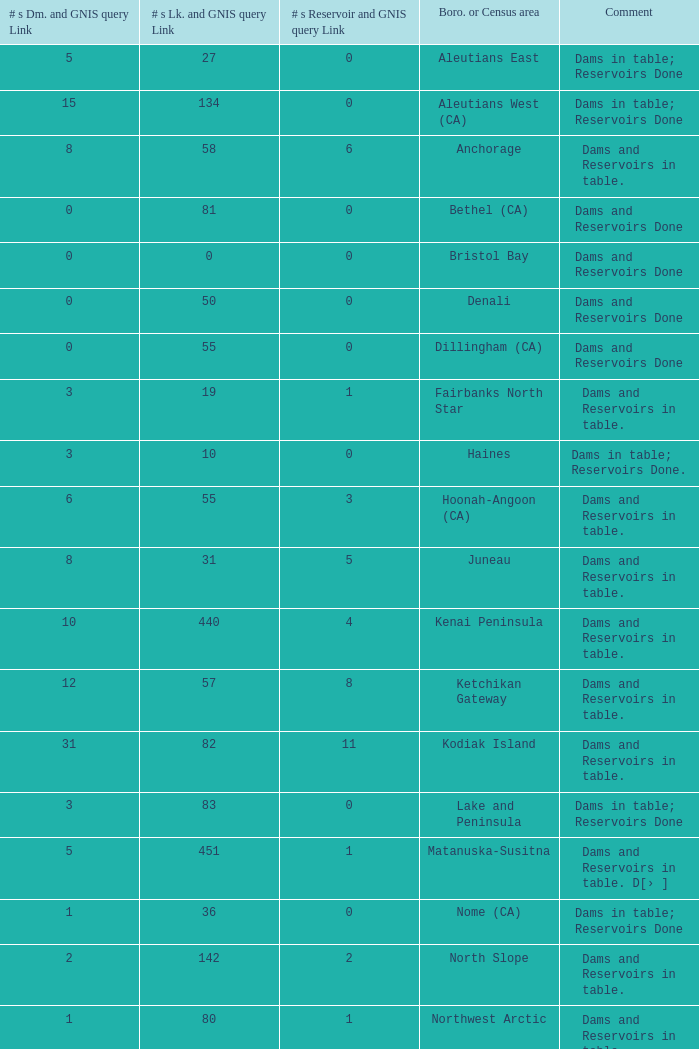Give me the full table as a dictionary. {'header': ['# s Dm. and GNIS query Link', '# s Lk. and GNIS query Link', '# s Reservoir and GNIS query Link', 'Boro. or Census area', 'Comment'], 'rows': [['5', '27', '0', 'Aleutians East', 'Dams in table; Reservoirs Done'], ['15', '134', '0', 'Aleutians West (CA)', 'Dams in table; Reservoirs Done'], ['8', '58', '6', 'Anchorage', 'Dams and Reservoirs in table.'], ['0', '81', '0', 'Bethel (CA)', 'Dams and Reservoirs Done'], ['0', '0', '0', 'Bristol Bay', 'Dams and Reservoirs Done'], ['0', '50', '0', 'Denali', 'Dams and Reservoirs Done'], ['0', '55', '0', 'Dillingham (CA)', 'Dams and Reservoirs Done'], ['3', '19', '1', 'Fairbanks North Star', 'Dams and Reservoirs in table.'], ['3', '10', '0', 'Haines', 'Dams in table; Reservoirs Done.'], ['6', '55', '3', 'Hoonah-Angoon (CA)', 'Dams and Reservoirs in table.'], ['8', '31', '5', 'Juneau', 'Dams and Reservoirs in table.'], ['10', '440', '4', 'Kenai Peninsula', 'Dams and Reservoirs in table.'], ['12', '57', '8', 'Ketchikan Gateway', 'Dams and Reservoirs in table.'], ['31', '82', '11', 'Kodiak Island', 'Dams and Reservoirs in table.'], ['3', '83', '0', 'Lake and Peninsula', 'Dams in table; Reservoirs Done'], ['5', '451', '1', 'Matanuska-Susitna', 'Dams and Reservoirs in table. D[› ]'], ['1', '36', '0', 'Nome (CA)', 'Dams in table; Reservoirs Done'], ['2', '142', '2', 'North Slope', 'Dams and Reservoirs in table.'], ['1', '80', '1', 'Northwest Arctic', 'Dams and Reservoirs in table.'], ['9', '163', '4', 'P. of Wales-O. Ketchikan (CA)', 'Dams and Reservoirs in table.'], ['9', '90', '3', 'Sitka', 'Dams and Reservoirs in table.'], ['3', '9', '3', 'Skagway', 'Dams and Reservoirs in table.'], ['0', '130', '0', 'Southeast Fairbanks (CA)', 'Dams and Reservoirs in table.'], ['22', '293', '10', 'Valdez-Cordova (CA)', 'Dams and Reservoirs in table.'], ['1', '21', '0', 'Wade Hampton (CA)', 'Dams in table; Reservoirs Done'], ['8', '60', '5', 'Wrangell-Petersburg (CA)', 'Dams and Reservoirs in table.'], ['0', '26', '0', 'Yakutat', 'Dams and Reservoirs Done'], ['2', '513', '0', 'Yukon-Koyukuk (CA)', 'Dams in table; Reservoirs Done']]} Name the minimum number of reservoir for gnis query link where numbers lake gnis query link being 60 5.0. 